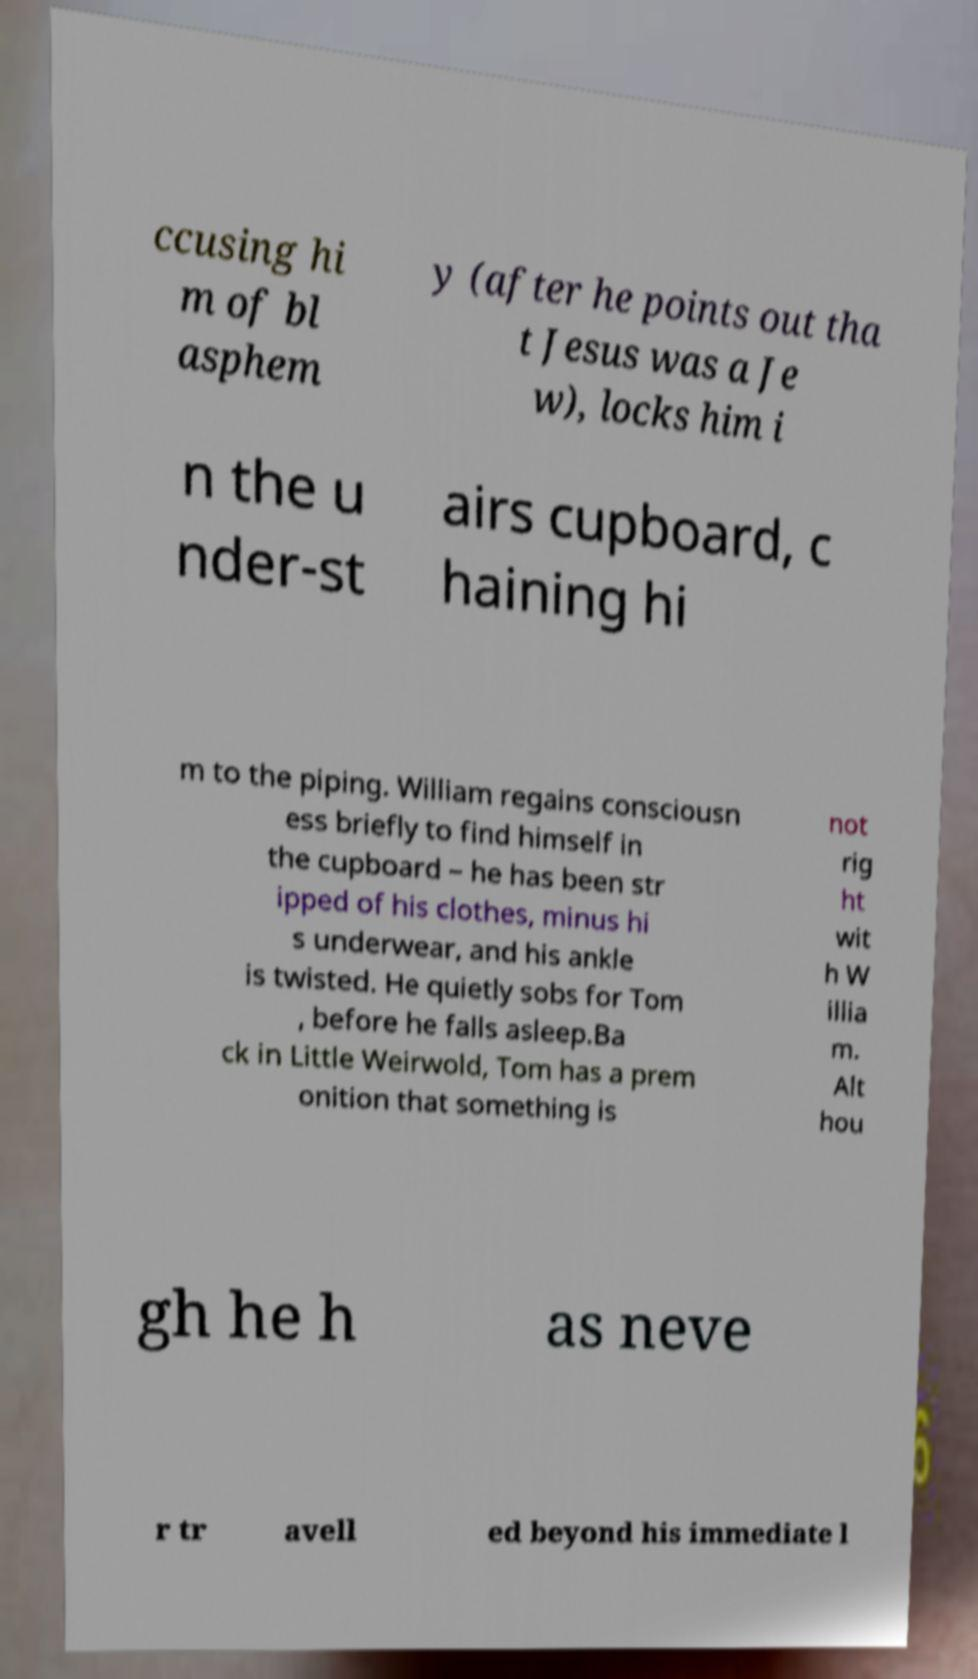I need the written content from this picture converted into text. Can you do that? ccusing hi m of bl asphem y (after he points out tha t Jesus was a Je w), locks him i n the u nder-st airs cupboard, c haining hi m to the piping. William regains consciousn ess briefly to find himself in the cupboard – he has been str ipped of his clothes, minus hi s underwear, and his ankle is twisted. He quietly sobs for Tom , before he falls asleep.Ba ck in Little Weirwold, Tom has a prem onition that something is not rig ht wit h W illia m. Alt hou gh he h as neve r tr avell ed beyond his immediate l 